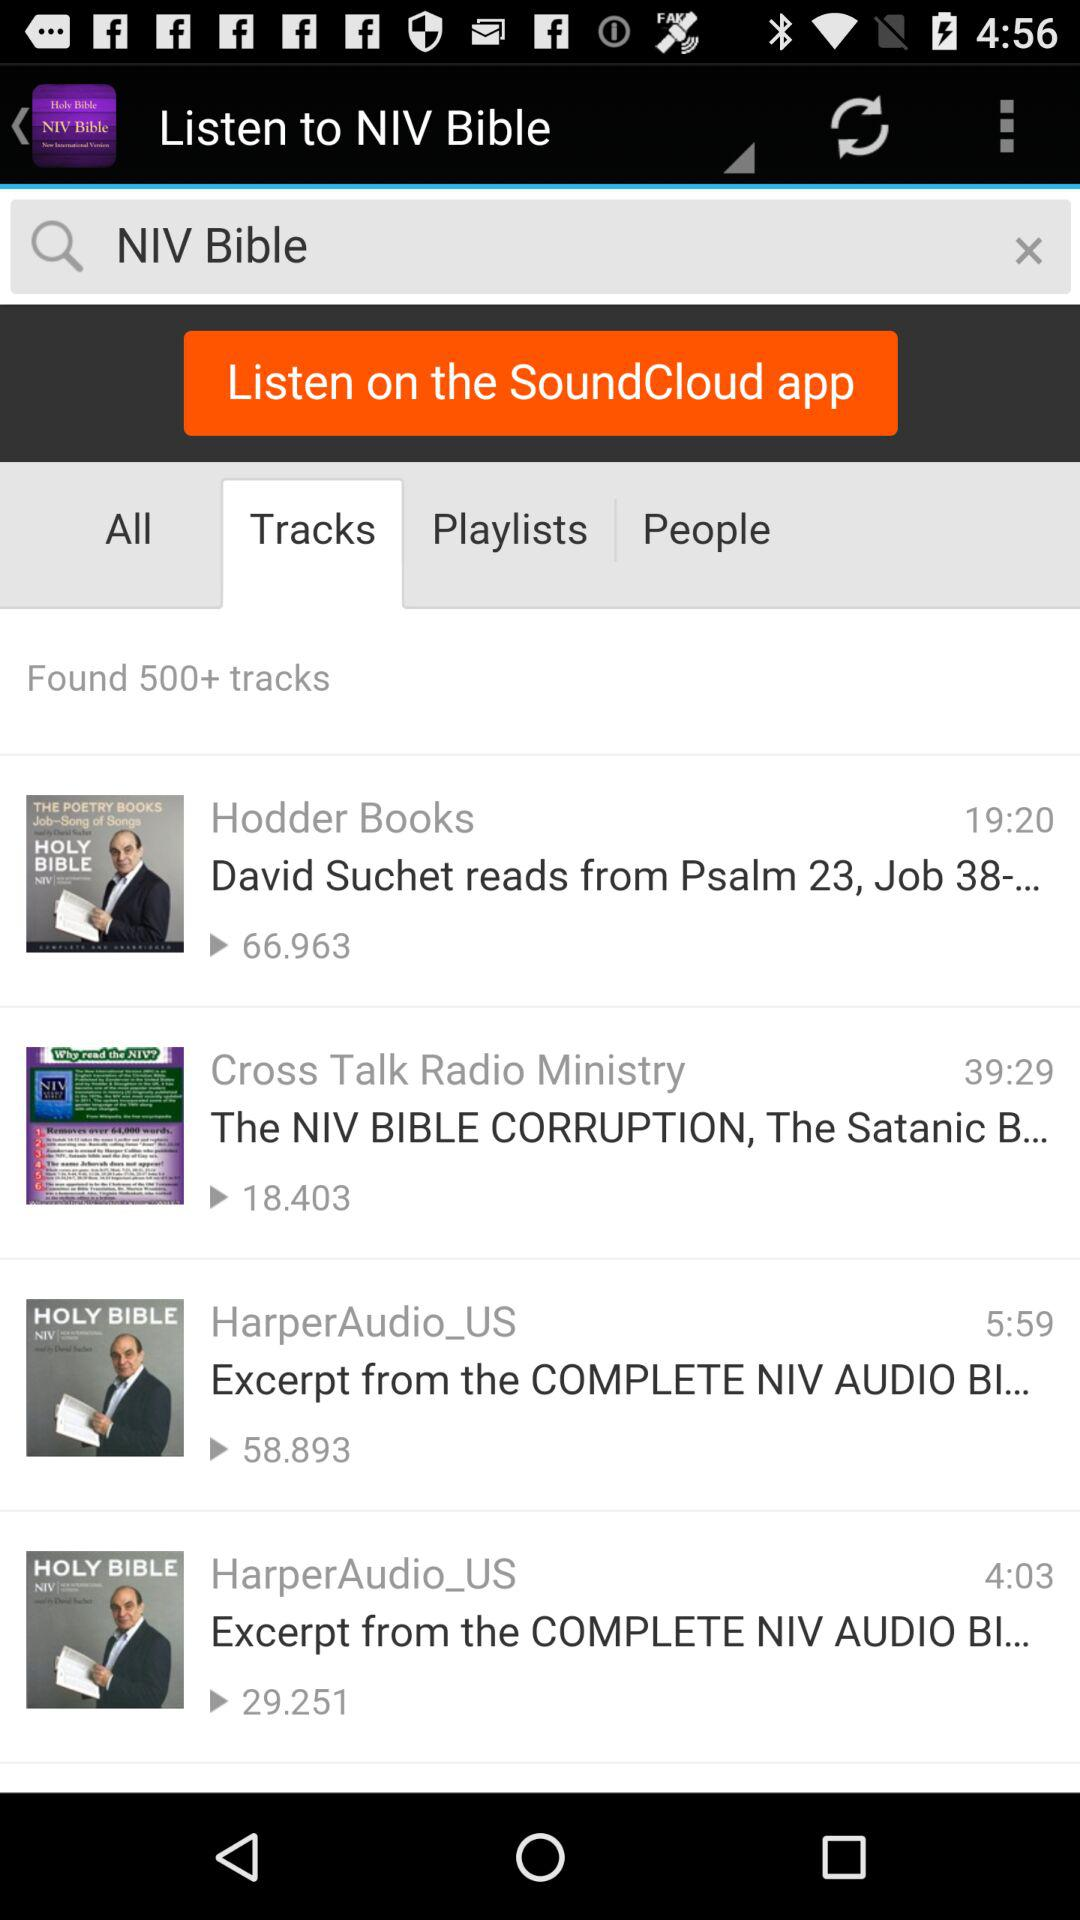What is the total views on cross talk radio ministry?
When the provided information is insufficient, respond with <no answer>. <no answer> 